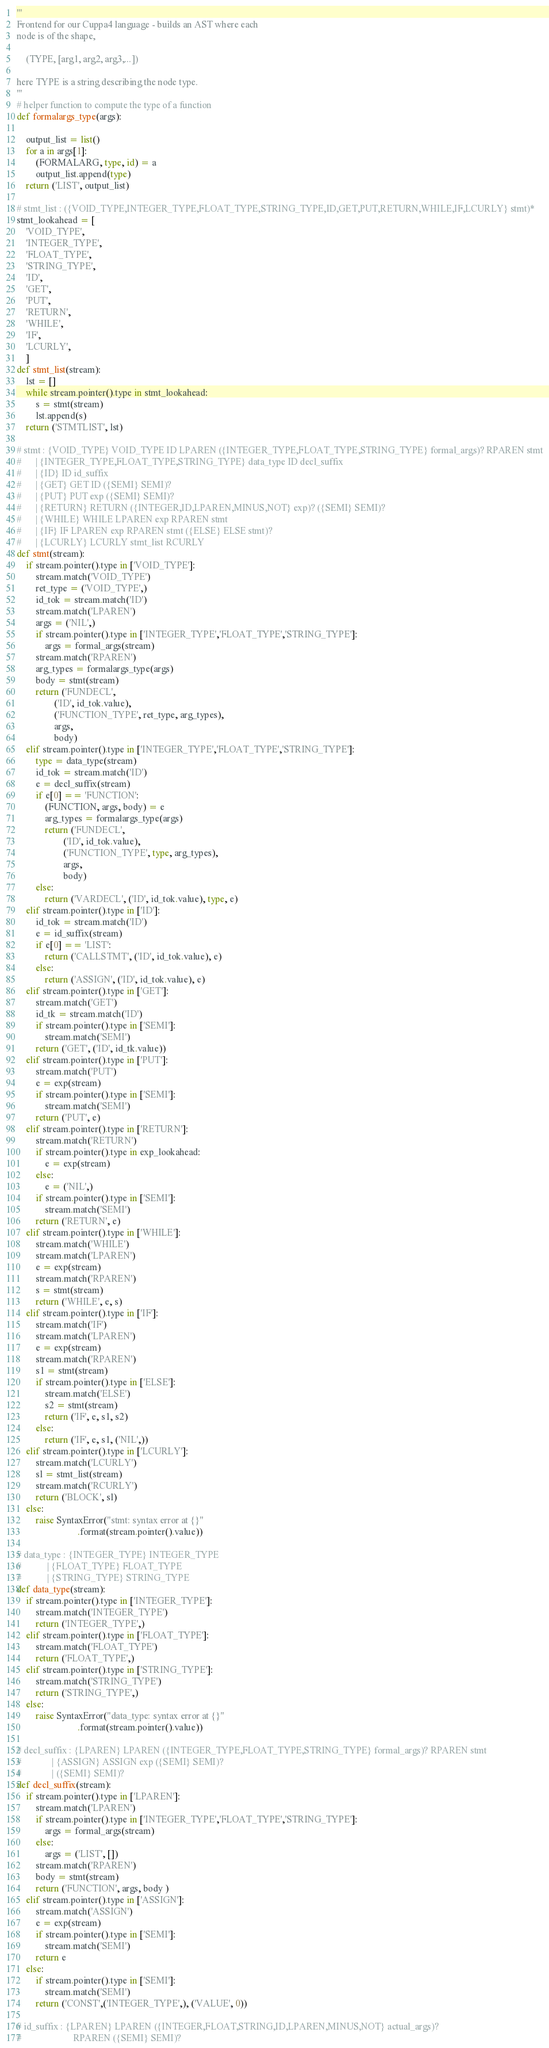Convert code to text. <code><loc_0><loc_0><loc_500><loc_500><_Python_>'''
Frontend for our Cuppa4 language - builds an AST where each
node is of the shape,

    (TYPE, [arg1, arg2, arg3,...])

here TYPE is a string describing the node type.
'''
# helper function to compute the type of a function
def formalargs_type(args):

    output_list = list()
    for a in args[1]:
        (FORMALARG, type, id) = a
        output_list.append(type)
    return ('LIST', output_list)

# stmt_list : ({VOID_TYPE,INTEGER_TYPE,FLOAT_TYPE,STRING_TYPE,ID,GET,PUT,RETURN,WHILE,IF,LCURLY} stmt)*
stmt_lookahead = [
    'VOID_TYPE',
    'INTEGER_TYPE',
    'FLOAT_TYPE',
    'STRING_TYPE',
    'ID',
    'GET',
    'PUT',
    'RETURN',
    'WHILE',
    'IF',
    'LCURLY',
    ]
def stmt_list(stream):
    lst = []
    while stream.pointer().type in stmt_lookahead:
        s = stmt(stream)
        lst.append(s)
    return ('STMTLIST', lst)

# stmt : {VOID_TYPE} VOID_TYPE ID LPAREN ({INTEGER_TYPE,FLOAT_TYPE,STRING_TYPE} formal_args)? RPAREN stmt
#      | {INTEGER_TYPE,FLOAT_TYPE,STRING_TYPE} data_type ID decl_suffix
#      | {ID} ID id_suffix
#      | {GET} GET ID ({SEMI} SEMI)?
#      | {PUT} PUT exp ({SEMI} SEMI)?
#      | {RETURN} RETURN ({INTEGER,ID,LPAREN,MINUS,NOT} exp)? ({SEMI} SEMI)?
#      | {WHILE} WHILE LPAREN exp RPAREN stmt
#      | {IF} IF LPAREN exp RPAREN stmt ({ELSE} ELSE stmt)?
#      | {LCURLY} LCURLY stmt_list RCURLY
def stmt(stream):
    if stream.pointer().type in ['VOID_TYPE']:
        stream.match('VOID_TYPE')
        ret_type = ('VOID_TYPE',)
        id_tok = stream.match('ID')
        stream.match('LPAREN')
        args = ('NIL',)
        if stream.pointer().type in ['INTEGER_TYPE','FLOAT_TYPE','STRING_TYPE']:
            args = formal_args(stream)
        stream.match('RPAREN')
        arg_types = formalargs_type(args)
        body = stmt(stream)
        return ('FUNDECL',
                ('ID', id_tok.value),
                ('FUNCTION_TYPE', ret_type, arg_types),
                args,
                body)
    elif stream.pointer().type in ['INTEGER_TYPE','FLOAT_TYPE','STRING_TYPE']:
        type = data_type(stream)
        id_tok = stream.match('ID')
        e = decl_suffix(stream)
        if e[0] == 'FUNCTION':
            (FUNCTION, args, body) = e
            arg_types = formalargs_type(args)
            return ('FUNDECL',
                    ('ID', id_tok.value),
                    ('FUNCTION_TYPE', type, arg_types),
                    args,
                    body)
        else:
            return ('VARDECL', ('ID', id_tok.value), type, e)
    elif stream.pointer().type in ['ID']:
        id_tok = stream.match('ID')
        e = id_suffix(stream)
        if e[0] == 'LIST':
            return ('CALLSTMT', ('ID', id_tok.value), e)
        else:
            return ('ASSIGN', ('ID', id_tok.value), e)
    elif stream.pointer().type in ['GET']:
        stream.match('GET')
        id_tk = stream.match('ID')
        if stream.pointer().type in ['SEMI']:
            stream.match('SEMI')
        return ('GET', ('ID', id_tk.value))
    elif stream.pointer().type in ['PUT']:
        stream.match('PUT')
        e = exp(stream)
        if stream.pointer().type in ['SEMI']:
            stream.match('SEMI')
        return ('PUT', e)
    elif stream.pointer().type in ['RETURN']:
        stream.match('RETURN')
        if stream.pointer().type in exp_lookahead:
            e = exp(stream)
        else:
            e = ('NIL',)
        if stream.pointer().type in ['SEMI']:
            stream.match('SEMI')
        return ('RETURN', e)
    elif stream.pointer().type in ['WHILE']:
        stream.match('WHILE')
        stream.match('LPAREN')
        e = exp(stream)
        stream.match('RPAREN')
        s = stmt(stream)
        return ('WHILE', e, s)
    elif stream.pointer().type in ['IF']:
        stream.match('IF')
        stream.match('LPAREN')
        e = exp(stream)
        stream.match('RPAREN')
        s1 = stmt(stream)
        if stream.pointer().type in ['ELSE']:
            stream.match('ELSE')
            s2 = stmt(stream)
            return ('IF', e, s1, s2)
        else:
            return ('IF', e, s1, ('NIL',))
    elif stream.pointer().type in ['LCURLY']:
        stream.match('LCURLY')
        sl = stmt_list(stream)
        stream.match('RCURLY')
        return ('BLOCK', sl)
    else:
        raise SyntaxError("stmt: syntax error at {}"
                          .format(stream.pointer().value))

# data_type : {INTEGER_TYPE} INTEGER_TYPE
#           | {FLOAT_TYPE} FLOAT_TYPE
#           | {STRING_TYPE} STRING_TYPE
def data_type(stream):
    if stream.pointer().type in ['INTEGER_TYPE']:
        stream.match('INTEGER_TYPE')
        return ('INTEGER_TYPE',)
    elif stream.pointer().type in ['FLOAT_TYPE']:
        stream.match('FLOAT_TYPE')
        return ('FLOAT_TYPE',)
    elif stream.pointer().type in ['STRING_TYPE']:
        stream.match('STRING_TYPE')
        return ('STRING_TYPE',)
    else:
        raise SyntaxError("data_type: syntax error at {}"
                          .format(stream.pointer().value))

# decl_suffix : {LPAREN} LPAREN ({INTEGER_TYPE,FLOAT_TYPE,STRING_TYPE} formal_args)? RPAREN stmt
#             | {ASSIGN} ASSIGN exp ({SEMI} SEMI)?
#             | ({SEMI} SEMI)?
def decl_suffix(stream):
    if stream.pointer().type in ['LPAREN']:
        stream.match('LPAREN')
        if stream.pointer().type in ['INTEGER_TYPE','FLOAT_TYPE','STRING_TYPE']:
            args = formal_args(stream)
        else:
            args = ('LIST', [])
        stream.match('RPAREN')
        body = stmt(stream)
        return ('FUNCTION', args, body )
    elif stream.pointer().type in ['ASSIGN']:
        stream.match('ASSIGN')
        e = exp(stream)
        if stream.pointer().type in ['SEMI']:
            stream.match('SEMI')
        return e
    else:
        if stream.pointer().type in ['SEMI']:
            stream.match('SEMI')
        return ('CONST',('INTEGER_TYPE',), ('VALUE', 0))

# id_suffix : {LPAREN} LPAREN ({INTEGER,FLOAT,STRING,ID,LPAREN,MINUS,NOT} actual_args)?
#                      RPAREN ({SEMI} SEMI)?</code> 